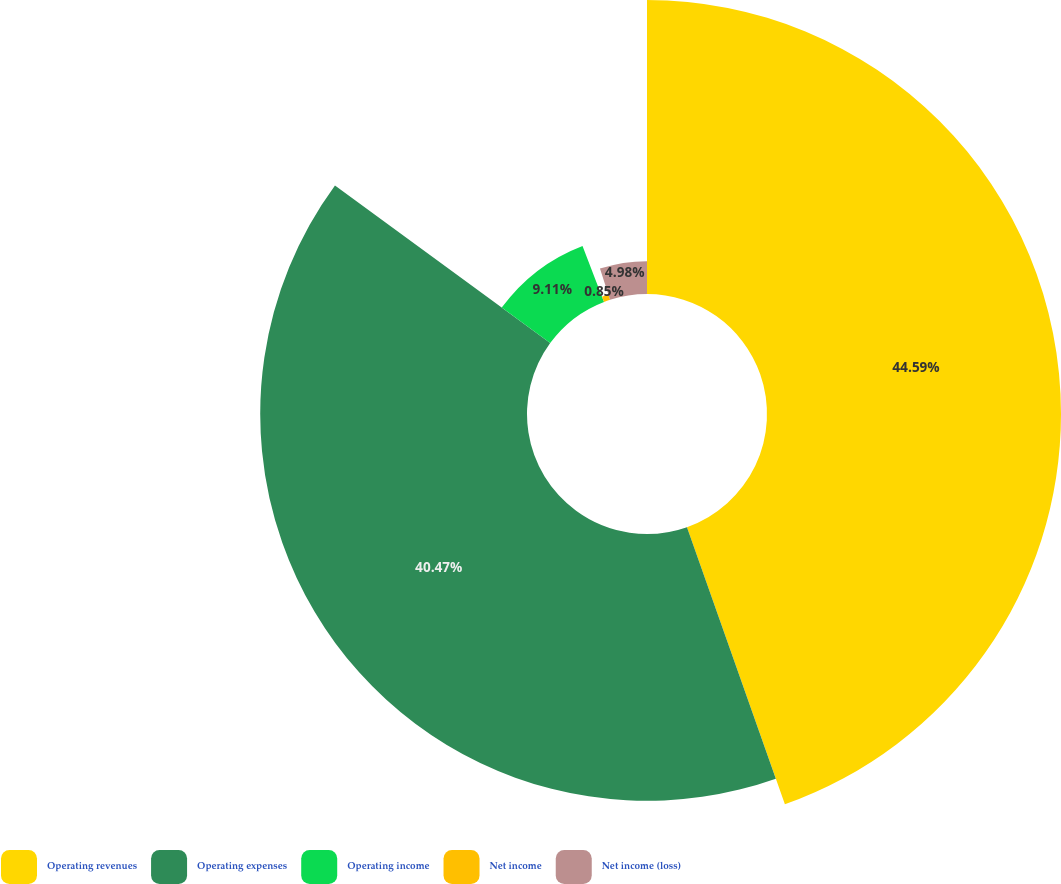Convert chart to OTSL. <chart><loc_0><loc_0><loc_500><loc_500><pie_chart><fcel>Operating revenues<fcel>Operating expenses<fcel>Operating income<fcel>Net income<fcel>Net income (loss)<nl><fcel>44.6%<fcel>40.47%<fcel>9.11%<fcel>0.85%<fcel>4.98%<nl></chart> 